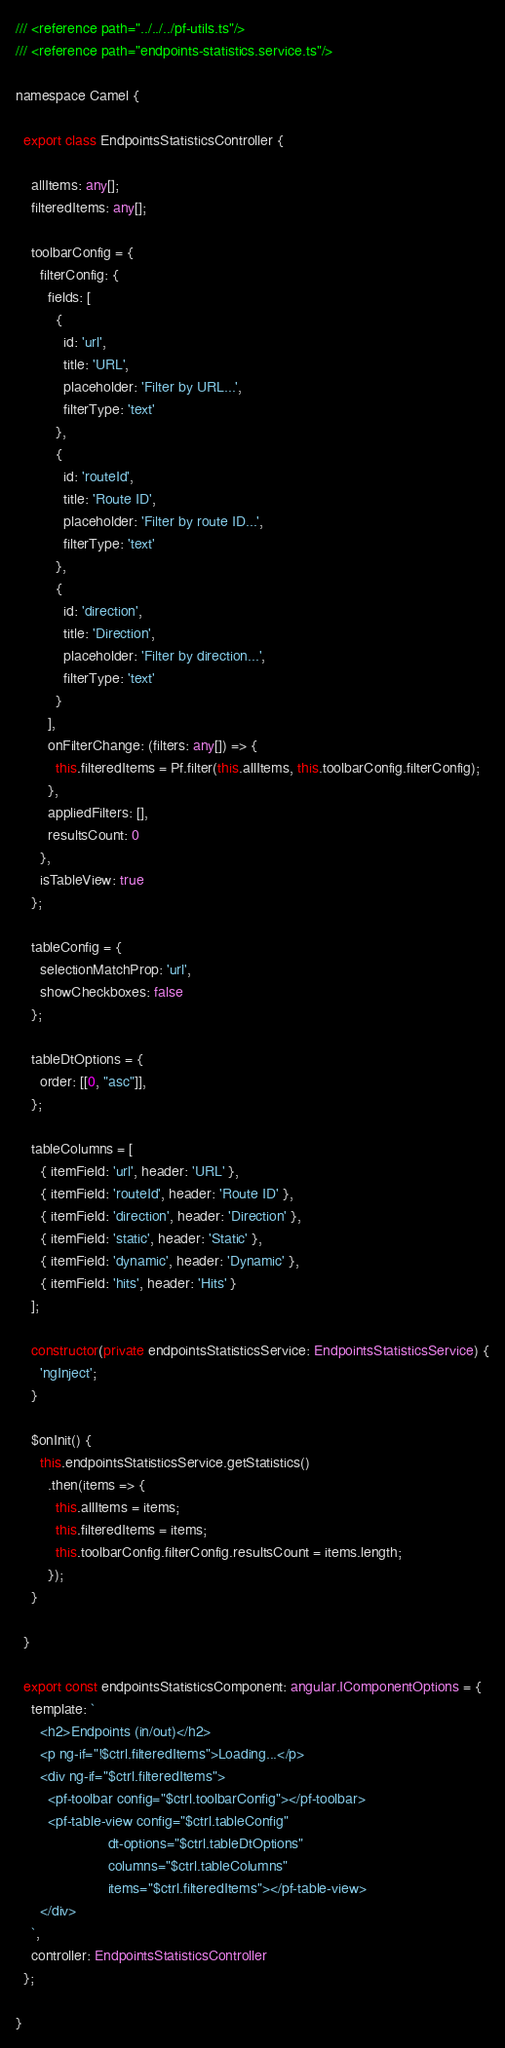Convert code to text. <code><loc_0><loc_0><loc_500><loc_500><_TypeScript_>/// <reference path="../../../pf-utils.ts"/>
/// <reference path="endpoints-statistics.service.ts"/>

namespace Camel {

  export class EndpointsStatisticsController {

    allItems: any[];
    filteredItems: any[];

    toolbarConfig = {
      filterConfig: {
        fields: [
          {
            id: 'url',
            title: 'URL',
            placeholder: 'Filter by URL...',
            filterType: 'text'
          },
          {
            id: 'routeId',
            title: 'Route ID',
            placeholder: 'Filter by route ID...',
            filterType: 'text'
          },
          {
            id: 'direction',
            title: 'Direction',
            placeholder: 'Filter by direction...',
            filterType: 'text'
          }
        ],
        onFilterChange: (filters: any[]) => {
          this.filteredItems = Pf.filter(this.allItems, this.toolbarConfig.filterConfig);
        },
        appliedFilters: [],
        resultsCount: 0
      },
      isTableView: true
    };

    tableConfig = {
      selectionMatchProp: 'url',
      showCheckboxes: false
    };
    
    tableDtOptions = {
      order: [[0, "asc"]],
    };

    tableColumns = [
      { itemField: 'url', header: 'URL' },
      { itemField: 'routeId', header: 'Route ID' },
      { itemField: 'direction', header: 'Direction' },
      { itemField: 'static', header: 'Static' },
      { itemField: 'dynamic', header: 'Dynamic' },
      { itemField: 'hits', header: 'Hits' }
    ];
    
    constructor(private endpointsStatisticsService: EndpointsStatisticsService) {
      'ngInject';
    }

    $onInit() {
      this.endpointsStatisticsService.getStatistics()
        .then(items => {
          this.allItems = items;
          this.filteredItems = items;
          this.toolbarConfig.filterConfig.resultsCount = items.length;
        });
    }

  }

  export const endpointsStatisticsComponent: angular.IComponentOptions = {
    template: `
      <h2>Endpoints (in/out)</h2>
      <p ng-if="!$ctrl.filteredItems">Loading...</p>
      <div ng-if="$ctrl.filteredItems">
        <pf-toolbar config="$ctrl.toolbarConfig"></pf-toolbar>
        <pf-table-view config="$ctrl.tableConfig"
                       dt-options="$ctrl.tableDtOptions"
                       columns="$ctrl.tableColumns"
                       items="$ctrl.filteredItems"></pf-table-view>
      </div>
    `,
    controller: EndpointsStatisticsController
  };  

}
</code> 